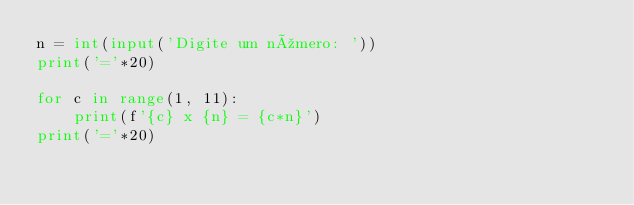<code> <loc_0><loc_0><loc_500><loc_500><_Python_>n = int(input('Digite um número: '))
print('='*20)

for c in range(1, 11):
    print(f'{c} x {n} = {c*n}')
print('='*20)
</code> 